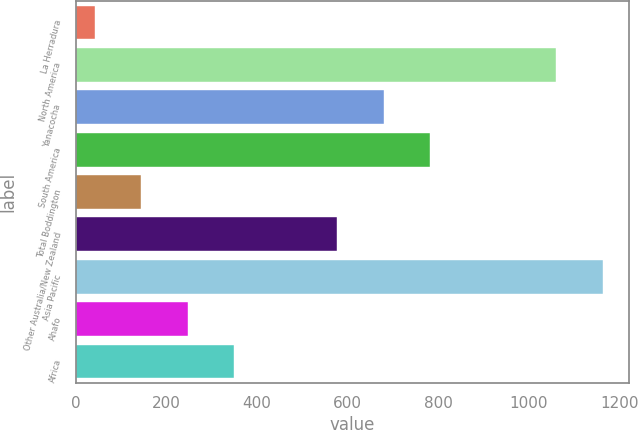Convert chart to OTSL. <chart><loc_0><loc_0><loc_500><loc_500><bar_chart><fcel>La Herradura<fcel>North America<fcel>Yanacocha<fcel>South America<fcel>Total Boddington<fcel>Other Australia/New Zealand<fcel>Asia Pacific<fcel>Ahafo<fcel>Africa<nl><fcel>42<fcel>1061<fcel>679.1<fcel>781.2<fcel>144.1<fcel>577<fcel>1163.1<fcel>246.2<fcel>348.3<nl></chart> 